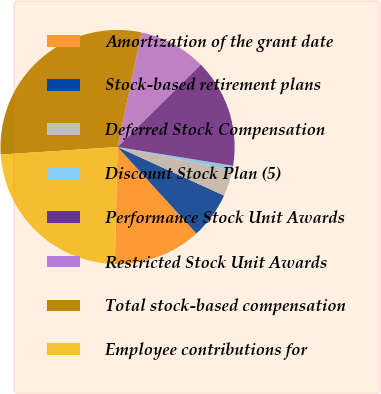<chart> <loc_0><loc_0><loc_500><loc_500><pie_chart><fcel>Amortization of the grant date<fcel>Stock-based retirement plans<fcel>Deferred Stock Compensation<fcel>Discount Stock Plan (5)<fcel>Performance Stock Unit Awards<fcel>Restricted Stock Unit Awards<fcel>Total stock-based compensation<fcel>Employee contributions for<nl><fcel>12.14%<fcel>6.42%<fcel>3.56%<fcel>0.69%<fcel>15.0%<fcel>9.28%<fcel>29.31%<fcel>23.59%<nl></chart> 